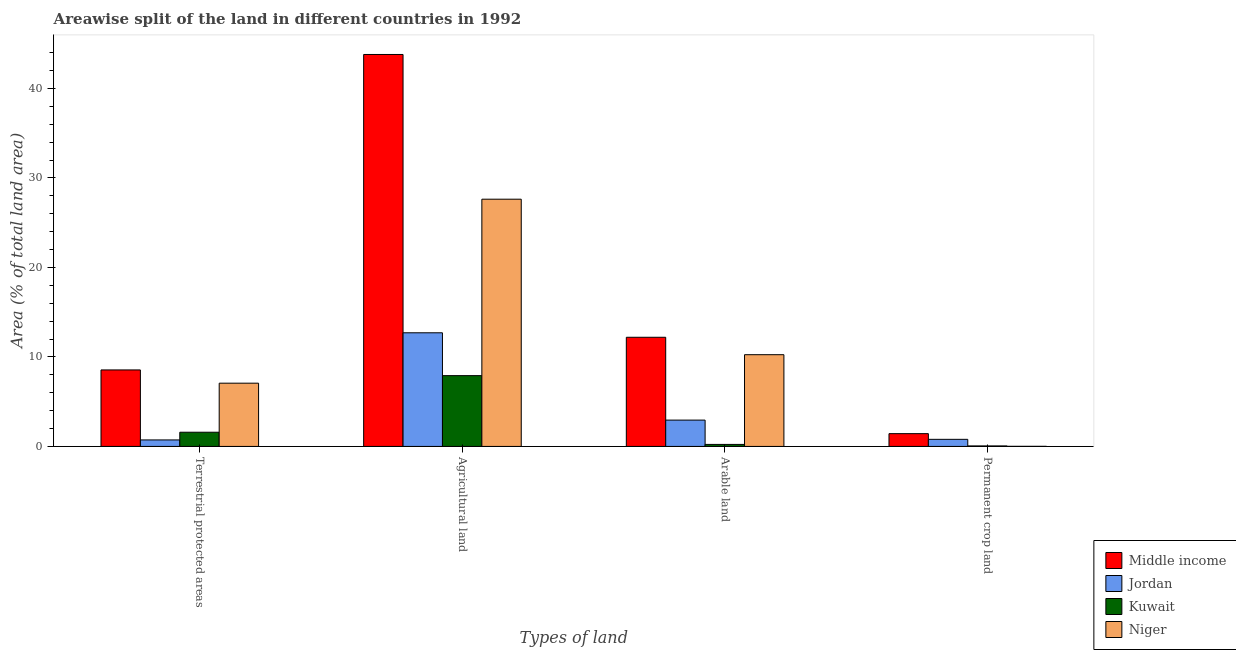How many groups of bars are there?
Keep it short and to the point. 4. How many bars are there on the 4th tick from the right?
Provide a succinct answer. 4. What is the label of the 4th group of bars from the left?
Provide a succinct answer. Permanent crop land. What is the percentage of area under arable land in Kuwait?
Keep it short and to the point. 0.22. Across all countries, what is the maximum percentage of area under arable land?
Your answer should be compact. 12.2. Across all countries, what is the minimum percentage of area under agricultural land?
Ensure brevity in your answer.  7.91. In which country was the percentage of area under permanent crop land maximum?
Your response must be concise. Middle income. In which country was the percentage of land under terrestrial protection minimum?
Make the answer very short. Jordan. What is the total percentage of land under terrestrial protection in the graph?
Ensure brevity in your answer.  17.93. What is the difference between the percentage of area under agricultural land in Middle income and that in Niger?
Offer a terse response. 16.17. What is the difference between the percentage of land under terrestrial protection in Kuwait and the percentage of area under permanent crop land in Middle income?
Your response must be concise. 0.16. What is the average percentage of area under permanent crop land per country?
Your answer should be very brief. 0.57. What is the difference between the percentage of area under arable land and percentage of area under permanent crop land in Jordan?
Provide a short and direct response. 2.15. What is the ratio of the percentage of area under permanent crop land in Niger to that in Jordan?
Make the answer very short. 0.01. Is the percentage of area under permanent crop land in Middle income less than that in Kuwait?
Provide a short and direct response. No. What is the difference between the highest and the second highest percentage of area under permanent crop land?
Offer a very short reply. 0.64. What is the difference between the highest and the lowest percentage of area under permanent crop land?
Keep it short and to the point. 1.42. In how many countries, is the percentage of area under agricultural land greater than the average percentage of area under agricultural land taken over all countries?
Keep it short and to the point. 2. Is the sum of the percentage of area under permanent crop land in Niger and Jordan greater than the maximum percentage of land under terrestrial protection across all countries?
Your answer should be very brief. No. Is it the case that in every country, the sum of the percentage of area under permanent crop land and percentage of area under agricultural land is greater than the sum of percentage of land under terrestrial protection and percentage of area under arable land?
Offer a very short reply. Yes. What does the 2nd bar from the left in Terrestrial protected areas represents?
Offer a very short reply. Jordan. What does the 3rd bar from the right in Permanent crop land represents?
Keep it short and to the point. Jordan. How many countries are there in the graph?
Provide a succinct answer. 4. Does the graph contain any zero values?
Offer a terse response. No. How are the legend labels stacked?
Make the answer very short. Vertical. What is the title of the graph?
Your response must be concise. Areawise split of the land in different countries in 1992. Does "Costa Rica" appear as one of the legend labels in the graph?
Offer a terse response. No. What is the label or title of the X-axis?
Offer a very short reply. Types of land. What is the label or title of the Y-axis?
Make the answer very short. Area (% of total land area). What is the Area (% of total land area) of Middle income in Terrestrial protected areas?
Ensure brevity in your answer.  8.55. What is the Area (% of total land area) in Jordan in Terrestrial protected areas?
Offer a very short reply. 0.73. What is the Area (% of total land area) in Kuwait in Terrestrial protected areas?
Give a very brief answer. 1.59. What is the Area (% of total land area) in Niger in Terrestrial protected areas?
Offer a terse response. 7.07. What is the Area (% of total land area) in Middle income in Agricultural land?
Ensure brevity in your answer.  43.8. What is the Area (% of total land area) of Jordan in Agricultural land?
Ensure brevity in your answer.  12.7. What is the Area (% of total land area) of Kuwait in Agricultural land?
Your response must be concise. 7.91. What is the Area (% of total land area) of Niger in Agricultural land?
Provide a succinct answer. 27.63. What is the Area (% of total land area) of Middle income in Arable land?
Give a very brief answer. 12.2. What is the Area (% of total land area) of Jordan in Arable land?
Your answer should be very brief. 2.94. What is the Area (% of total land area) of Kuwait in Arable land?
Your response must be concise. 0.22. What is the Area (% of total land area) of Niger in Arable land?
Your answer should be compact. 10.25. What is the Area (% of total land area) in Middle income in Permanent crop land?
Keep it short and to the point. 1.43. What is the Area (% of total land area) in Jordan in Permanent crop land?
Your answer should be very brief. 0.79. What is the Area (% of total land area) in Kuwait in Permanent crop land?
Make the answer very short. 0.06. What is the Area (% of total land area) in Niger in Permanent crop land?
Provide a succinct answer. 0.01. Across all Types of land, what is the maximum Area (% of total land area) of Middle income?
Keep it short and to the point. 43.8. Across all Types of land, what is the maximum Area (% of total land area) of Jordan?
Your answer should be very brief. 12.7. Across all Types of land, what is the maximum Area (% of total land area) in Kuwait?
Offer a very short reply. 7.91. Across all Types of land, what is the maximum Area (% of total land area) in Niger?
Keep it short and to the point. 27.63. Across all Types of land, what is the minimum Area (% of total land area) of Middle income?
Provide a succinct answer. 1.43. Across all Types of land, what is the minimum Area (% of total land area) of Jordan?
Your response must be concise. 0.73. Across all Types of land, what is the minimum Area (% of total land area) in Kuwait?
Provide a short and direct response. 0.06. Across all Types of land, what is the minimum Area (% of total land area) of Niger?
Give a very brief answer. 0.01. What is the total Area (% of total land area) in Middle income in the graph?
Give a very brief answer. 65.98. What is the total Area (% of total land area) in Jordan in the graph?
Provide a succinct answer. 17.16. What is the total Area (% of total land area) in Kuwait in the graph?
Your response must be concise. 9.78. What is the total Area (% of total land area) of Niger in the graph?
Offer a very short reply. 44.96. What is the difference between the Area (% of total land area) of Middle income in Terrestrial protected areas and that in Agricultural land?
Make the answer very short. -35.26. What is the difference between the Area (% of total land area) in Jordan in Terrestrial protected areas and that in Agricultural land?
Offer a terse response. -11.97. What is the difference between the Area (% of total land area) of Kuwait in Terrestrial protected areas and that in Agricultural land?
Provide a short and direct response. -6.33. What is the difference between the Area (% of total land area) in Niger in Terrestrial protected areas and that in Agricultural land?
Offer a very short reply. -20.56. What is the difference between the Area (% of total land area) in Middle income in Terrestrial protected areas and that in Arable land?
Keep it short and to the point. -3.65. What is the difference between the Area (% of total land area) of Jordan in Terrestrial protected areas and that in Arable land?
Offer a very short reply. -2.22. What is the difference between the Area (% of total land area) of Kuwait in Terrestrial protected areas and that in Arable land?
Provide a succinct answer. 1.36. What is the difference between the Area (% of total land area) of Niger in Terrestrial protected areas and that in Arable land?
Your answer should be compact. -3.18. What is the difference between the Area (% of total land area) in Middle income in Terrestrial protected areas and that in Permanent crop land?
Your answer should be very brief. 7.12. What is the difference between the Area (% of total land area) of Jordan in Terrestrial protected areas and that in Permanent crop land?
Offer a terse response. -0.07. What is the difference between the Area (% of total land area) in Kuwait in Terrestrial protected areas and that in Permanent crop land?
Keep it short and to the point. 1.53. What is the difference between the Area (% of total land area) in Niger in Terrestrial protected areas and that in Permanent crop land?
Provide a short and direct response. 7.06. What is the difference between the Area (% of total land area) in Middle income in Agricultural land and that in Arable land?
Provide a short and direct response. 31.61. What is the difference between the Area (% of total land area) of Jordan in Agricultural land and that in Arable land?
Provide a succinct answer. 9.76. What is the difference between the Area (% of total land area) of Kuwait in Agricultural land and that in Arable land?
Give a very brief answer. 7.69. What is the difference between the Area (% of total land area) in Niger in Agricultural land and that in Arable land?
Your answer should be very brief. 17.38. What is the difference between the Area (% of total land area) in Middle income in Agricultural land and that in Permanent crop land?
Your response must be concise. 42.38. What is the difference between the Area (% of total land area) of Jordan in Agricultural land and that in Permanent crop land?
Your response must be concise. 11.91. What is the difference between the Area (% of total land area) in Kuwait in Agricultural land and that in Permanent crop land?
Offer a terse response. 7.86. What is the difference between the Area (% of total land area) in Niger in Agricultural land and that in Permanent crop land?
Provide a short and direct response. 27.62. What is the difference between the Area (% of total land area) of Middle income in Arable land and that in Permanent crop land?
Ensure brevity in your answer.  10.77. What is the difference between the Area (% of total land area) in Jordan in Arable land and that in Permanent crop land?
Offer a very short reply. 2.15. What is the difference between the Area (% of total land area) in Kuwait in Arable land and that in Permanent crop land?
Your response must be concise. 0.17. What is the difference between the Area (% of total land area) in Niger in Arable land and that in Permanent crop land?
Provide a short and direct response. 10.24. What is the difference between the Area (% of total land area) in Middle income in Terrestrial protected areas and the Area (% of total land area) in Jordan in Agricultural land?
Your answer should be very brief. -4.15. What is the difference between the Area (% of total land area) in Middle income in Terrestrial protected areas and the Area (% of total land area) in Kuwait in Agricultural land?
Offer a very short reply. 0.64. What is the difference between the Area (% of total land area) of Middle income in Terrestrial protected areas and the Area (% of total land area) of Niger in Agricultural land?
Provide a short and direct response. -19.08. What is the difference between the Area (% of total land area) of Jordan in Terrestrial protected areas and the Area (% of total land area) of Kuwait in Agricultural land?
Provide a succinct answer. -7.19. What is the difference between the Area (% of total land area) in Jordan in Terrestrial protected areas and the Area (% of total land area) in Niger in Agricultural land?
Ensure brevity in your answer.  -26.9. What is the difference between the Area (% of total land area) in Kuwait in Terrestrial protected areas and the Area (% of total land area) in Niger in Agricultural land?
Offer a very short reply. -26.04. What is the difference between the Area (% of total land area) of Middle income in Terrestrial protected areas and the Area (% of total land area) of Jordan in Arable land?
Your response must be concise. 5.61. What is the difference between the Area (% of total land area) of Middle income in Terrestrial protected areas and the Area (% of total land area) of Kuwait in Arable land?
Your response must be concise. 8.32. What is the difference between the Area (% of total land area) of Middle income in Terrestrial protected areas and the Area (% of total land area) of Niger in Arable land?
Your answer should be very brief. -1.7. What is the difference between the Area (% of total land area) in Jordan in Terrestrial protected areas and the Area (% of total land area) in Kuwait in Arable land?
Ensure brevity in your answer.  0.5. What is the difference between the Area (% of total land area) of Jordan in Terrestrial protected areas and the Area (% of total land area) of Niger in Arable land?
Ensure brevity in your answer.  -9.53. What is the difference between the Area (% of total land area) of Kuwait in Terrestrial protected areas and the Area (% of total land area) of Niger in Arable land?
Provide a short and direct response. -8.67. What is the difference between the Area (% of total land area) in Middle income in Terrestrial protected areas and the Area (% of total land area) in Jordan in Permanent crop land?
Offer a terse response. 7.76. What is the difference between the Area (% of total land area) in Middle income in Terrestrial protected areas and the Area (% of total land area) in Kuwait in Permanent crop land?
Your answer should be compact. 8.49. What is the difference between the Area (% of total land area) of Middle income in Terrestrial protected areas and the Area (% of total land area) of Niger in Permanent crop land?
Your answer should be compact. 8.54. What is the difference between the Area (% of total land area) of Jordan in Terrestrial protected areas and the Area (% of total land area) of Kuwait in Permanent crop land?
Give a very brief answer. 0.67. What is the difference between the Area (% of total land area) of Jordan in Terrestrial protected areas and the Area (% of total land area) of Niger in Permanent crop land?
Your answer should be very brief. 0.72. What is the difference between the Area (% of total land area) in Kuwait in Terrestrial protected areas and the Area (% of total land area) in Niger in Permanent crop land?
Keep it short and to the point. 1.58. What is the difference between the Area (% of total land area) in Middle income in Agricultural land and the Area (% of total land area) in Jordan in Arable land?
Offer a terse response. 40.86. What is the difference between the Area (% of total land area) in Middle income in Agricultural land and the Area (% of total land area) in Kuwait in Arable land?
Give a very brief answer. 43.58. What is the difference between the Area (% of total land area) in Middle income in Agricultural land and the Area (% of total land area) in Niger in Arable land?
Offer a very short reply. 33.55. What is the difference between the Area (% of total land area) in Jordan in Agricultural land and the Area (% of total land area) in Kuwait in Arable land?
Provide a short and direct response. 12.48. What is the difference between the Area (% of total land area) of Jordan in Agricultural land and the Area (% of total land area) of Niger in Arable land?
Provide a short and direct response. 2.45. What is the difference between the Area (% of total land area) of Kuwait in Agricultural land and the Area (% of total land area) of Niger in Arable land?
Your answer should be compact. -2.34. What is the difference between the Area (% of total land area) in Middle income in Agricultural land and the Area (% of total land area) in Jordan in Permanent crop land?
Keep it short and to the point. 43.01. What is the difference between the Area (% of total land area) of Middle income in Agricultural land and the Area (% of total land area) of Kuwait in Permanent crop land?
Offer a very short reply. 43.75. What is the difference between the Area (% of total land area) in Middle income in Agricultural land and the Area (% of total land area) in Niger in Permanent crop land?
Ensure brevity in your answer.  43.79. What is the difference between the Area (% of total land area) in Jordan in Agricultural land and the Area (% of total land area) in Kuwait in Permanent crop land?
Keep it short and to the point. 12.64. What is the difference between the Area (% of total land area) in Jordan in Agricultural land and the Area (% of total land area) in Niger in Permanent crop land?
Your answer should be very brief. 12.69. What is the difference between the Area (% of total land area) in Kuwait in Agricultural land and the Area (% of total land area) in Niger in Permanent crop land?
Provide a short and direct response. 7.9. What is the difference between the Area (% of total land area) of Middle income in Arable land and the Area (% of total land area) of Jordan in Permanent crop land?
Provide a succinct answer. 11.41. What is the difference between the Area (% of total land area) in Middle income in Arable land and the Area (% of total land area) in Kuwait in Permanent crop land?
Provide a succinct answer. 12.14. What is the difference between the Area (% of total land area) of Middle income in Arable land and the Area (% of total land area) of Niger in Permanent crop land?
Your answer should be compact. 12.19. What is the difference between the Area (% of total land area) of Jordan in Arable land and the Area (% of total land area) of Kuwait in Permanent crop land?
Ensure brevity in your answer.  2.89. What is the difference between the Area (% of total land area) of Jordan in Arable land and the Area (% of total land area) of Niger in Permanent crop land?
Keep it short and to the point. 2.93. What is the difference between the Area (% of total land area) in Kuwait in Arable land and the Area (% of total land area) in Niger in Permanent crop land?
Ensure brevity in your answer.  0.21. What is the average Area (% of total land area) of Middle income per Types of land?
Provide a short and direct response. 16.5. What is the average Area (% of total land area) in Jordan per Types of land?
Your answer should be very brief. 4.29. What is the average Area (% of total land area) of Kuwait per Types of land?
Provide a short and direct response. 2.44. What is the average Area (% of total land area) of Niger per Types of land?
Your response must be concise. 11.24. What is the difference between the Area (% of total land area) of Middle income and Area (% of total land area) of Jordan in Terrestrial protected areas?
Your answer should be compact. 7.82. What is the difference between the Area (% of total land area) of Middle income and Area (% of total land area) of Kuwait in Terrestrial protected areas?
Your answer should be very brief. 6.96. What is the difference between the Area (% of total land area) of Middle income and Area (% of total land area) of Niger in Terrestrial protected areas?
Your answer should be compact. 1.48. What is the difference between the Area (% of total land area) in Jordan and Area (% of total land area) in Kuwait in Terrestrial protected areas?
Provide a succinct answer. -0.86. What is the difference between the Area (% of total land area) in Jordan and Area (% of total land area) in Niger in Terrestrial protected areas?
Your answer should be very brief. -6.34. What is the difference between the Area (% of total land area) of Kuwait and Area (% of total land area) of Niger in Terrestrial protected areas?
Make the answer very short. -5.48. What is the difference between the Area (% of total land area) of Middle income and Area (% of total land area) of Jordan in Agricultural land?
Make the answer very short. 31.1. What is the difference between the Area (% of total land area) of Middle income and Area (% of total land area) of Kuwait in Agricultural land?
Offer a terse response. 35.89. What is the difference between the Area (% of total land area) of Middle income and Area (% of total land area) of Niger in Agricultural land?
Offer a very short reply. 16.17. What is the difference between the Area (% of total land area) of Jordan and Area (% of total land area) of Kuwait in Agricultural land?
Keep it short and to the point. 4.79. What is the difference between the Area (% of total land area) in Jordan and Area (% of total land area) in Niger in Agricultural land?
Your answer should be very brief. -14.93. What is the difference between the Area (% of total land area) in Kuwait and Area (% of total land area) in Niger in Agricultural land?
Provide a succinct answer. -19.72. What is the difference between the Area (% of total land area) of Middle income and Area (% of total land area) of Jordan in Arable land?
Your response must be concise. 9.26. What is the difference between the Area (% of total land area) in Middle income and Area (% of total land area) in Kuwait in Arable land?
Your answer should be very brief. 11.97. What is the difference between the Area (% of total land area) in Middle income and Area (% of total land area) in Niger in Arable land?
Provide a succinct answer. 1.95. What is the difference between the Area (% of total land area) in Jordan and Area (% of total land area) in Kuwait in Arable land?
Your answer should be very brief. 2.72. What is the difference between the Area (% of total land area) of Jordan and Area (% of total land area) of Niger in Arable land?
Your answer should be very brief. -7.31. What is the difference between the Area (% of total land area) of Kuwait and Area (% of total land area) of Niger in Arable land?
Offer a very short reply. -10.03. What is the difference between the Area (% of total land area) of Middle income and Area (% of total land area) of Jordan in Permanent crop land?
Provide a short and direct response. 0.64. What is the difference between the Area (% of total land area) in Middle income and Area (% of total land area) in Kuwait in Permanent crop land?
Provide a succinct answer. 1.37. What is the difference between the Area (% of total land area) in Middle income and Area (% of total land area) in Niger in Permanent crop land?
Give a very brief answer. 1.42. What is the difference between the Area (% of total land area) of Jordan and Area (% of total land area) of Kuwait in Permanent crop land?
Your answer should be very brief. 0.74. What is the difference between the Area (% of total land area) in Jordan and Area (% of total land area) in Niger in Permanent crop land?
Offer a very short reply. 0.78. What is the difference between the Area (% of total land area) in Kuwait and Area (% of total land area) in Niger in Permanent crop land?
Provide a short and direct response. 0.05. What is the ratio of the Area (% of total land area) of Middle income in Terrestrial protected areas to that in Agricultural land?
Your response must be concise. 0.2. What is the ratio of the Area (% of total land area) of Jordan in Terrestrial protected areas to that in Agricultural land?
Make the answer very short. 0.06. What is the ratio of the Area (% of total land area) in Kuwait in Terrestrial protected areas to that in Agricultural land?
Give a very brief answer. 0.2. What is the ratio of the Area (% of total land area) in Niger in Terrestrial protected areas to that in Agricultural land?
Offer a very short reply. 0.26. What is the ratio of the Area (% of total land area) of Middle income in Terrestrial protected areas to that in Arable land?
Provide a succinct answer. 0.7. What is the ratio of the Area (% of total land area) in Jordan in Terrestrial protected areas to that in Arable land?
Ensure brevity in your answer.  0.25. What is the ratio of the Area (% of total land area) in Kuwait in Terrestrial protected areas to that in Arable land?
Your answer should be compact. 7.07. What is the ratio of the Area (% of total land area) of Niger in Terrestrial protected areas to that in Arable land?
Keep it short and to the point. 0.69. What is the ratio of the Area (% of total land area) of Middle income in Terrestrial protected areas to that in Permanent crop land?
Your answer should be very brief. 5.98. What is the ratio of the Area (% of total land area) in Jordan in Terrestrial protected areas to that in Permanent crop land?
Make the answer very short. 0.92. What is the ratio of the Area (% of total land area) in Kuwait in Terrestrial protected areas to that in Permanent crop land?
Give a very brief answer. 28.27. What is the ratio of the Area (% of total land area) of Niger in Terrestrial protected areas to that in Permanent crop land?
Provide a succinct answer. 688.82. What is the ratio of the Area (% of total land area) in Middle income in Agricultural land to that in Arable land?
Offer a terse response. 3.59. What is the ratio of the Area (% of total land area) of Jordan in Agricultural land to that in Arable land?
Offer a terse response. 4.32. What is the ratio of the Area (% of total land area) in Kuwait in Agricultural land to that in Arable land?
Give a very brief answer. 35.25. What is the ratio of the Area (% of total land area) of Niger in Agricultural land to that in Arable land?
Provide a succinct answer. 2.69. What is the ratio of the Area (% of total land area) in Middle income in Agricultural land to that in Permanent crop land?
Give a very brief answer. 30.65. What is the ratio of the Area (% of total land area) of Jordan in Agricultural land to that in Permanent crop land?
Offer a very short reply. 16.01. What is the ratio of the Area (% of total land area) in Kuwait in Agricultural land to that in Permanent crop land?
Offer a very short reply. 141. What is the ratio of the Area (% of total land area) in Niger in Agricultural land to that in Permanent crop land?
Provide a short and direct response. 2692.31. What is the ratio of the Area (% of total land area) of Middle income in Arable land to that in Permanent crop land?
Ensure brevity in your answer.  8.54. What is the ratio of the Area (% of total land area) in Jordan in Arable land to that in Permanent crop land?
Make the answer very short. 3.71. What is the ratio of the Area (% of total land area) of Kuwait in Arable land to that in Permanent crop land?
Offer a very short reply. 4. What is the ratio of the Area (% of total land area) of Niger in Arable land to that in Permanent crop land?
Provide a succinct answer. 999. What is the difference between the highest and the second highest Area (% of total land area) of Middle income?
Keep it short and to the point. 31.61. What is the difference between the highest and the second highest Area (% of total land area) in Jordan?
Your response must be concise. 9.76. What is the difference between the highest and the second highest Area (% of total land area) of Kuwait?
Keep it short and to the point. 6.33. What is the difference between the highest and the second highest Area (% of total land area) in Niger?
Your response must be concise. 17.38. What is the difference between the highest and the lowest Area (% of total land area) of Middle income?
Your answer should be very brief. 42.38. What is the difference between the highest and the lowest Area (% of total land area) of Jordan?
Your answer should be compact. 11.97. What is the difference between the highest and the lowest Area (% of total land area) in Kuwait?
Provide a short and direct response. 7.86. What is the difference between the highest and the lowest Area (% of total land area) in Niger?
Offer a terse response. 27.62. 